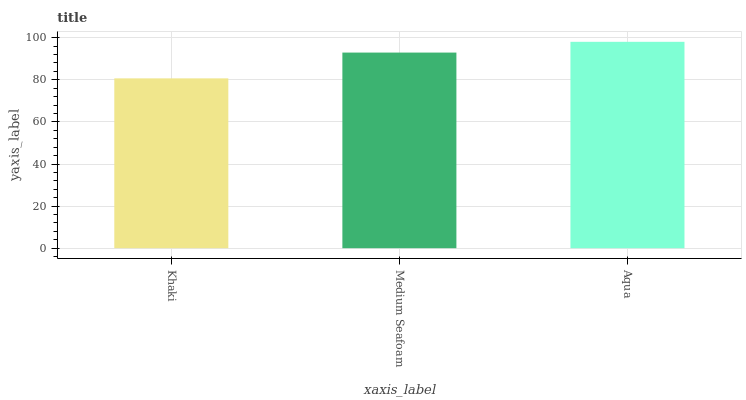Is Medium Seafoam the minimum?
Answer yes or no. No. Is Medium Seafoam the maximum?
Answer yes or no. No. Is Medium Seafoam greater than Khaki?
Answer yes or no. Yes. Is Khaki less than Medium Seafoam?
Answer yes or no. Yes. Is Khaki greater than Medium Seafoam?
Answer yes or no. No. Is Medium Seafoam less than Khaki?
Answer yes or no. No. Is Medium Seafoam the high median?
Answer yes or no. Yes. Is Medium Seafoam the low median?
Answer yes or no. Yes. Is Aqua the high median?
Answer yes or no. No. Is Khaki the low median?
Answer yes or no. No. 